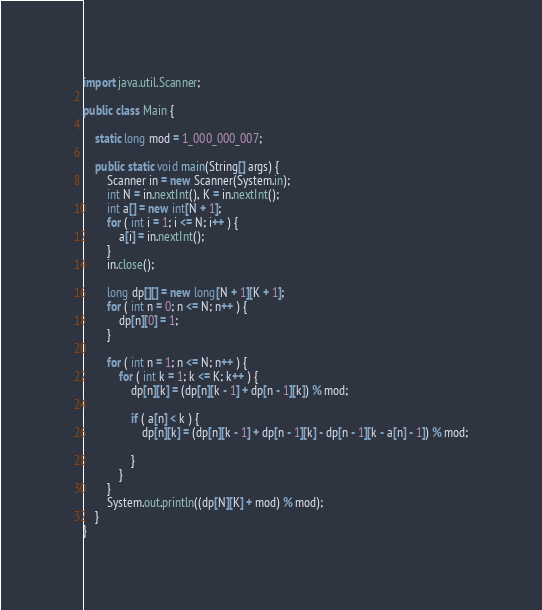Convert code to text. <code><loc_0><loc_0><loc_500><loc_500><_Java_>import java.util.Scanner;

public class Main {

	static long mod = 1_000_000_007;

	public static void main(String[] args) {
		Scanner in = new Scanner(System.in);
		int N = in.nextInt(), K = in.nextInt();
		int a[] = new int[N + 1];
		for ( int i = 1; i <= N; i++ ) {
			a[i] = in.nextInt();
		}
		in.close();

		long dp[][] = new long[N + 1][K + 1];
		for ( int n = 0; n <= N; n++ ) {
			dp[n][0] = 1;
		}

		for ( int n = 1; n <= N; n++ ) {
			for ( int k = 1; k <= K; k++ ) {
				dp[n][k] = (dp[n][k - 1] + dp[n - 1][k]) % mod;

				if ( a[n] < k ) {
					dp[n][k] = (dp[n][k - 1] + dp[n - 1][k] - dp[n - 1][k - a[n] - 1]) % mod;

				}
			}
		}
		System.out.println((dp[N][K] + mod) % mod);
	}
}
</code> 